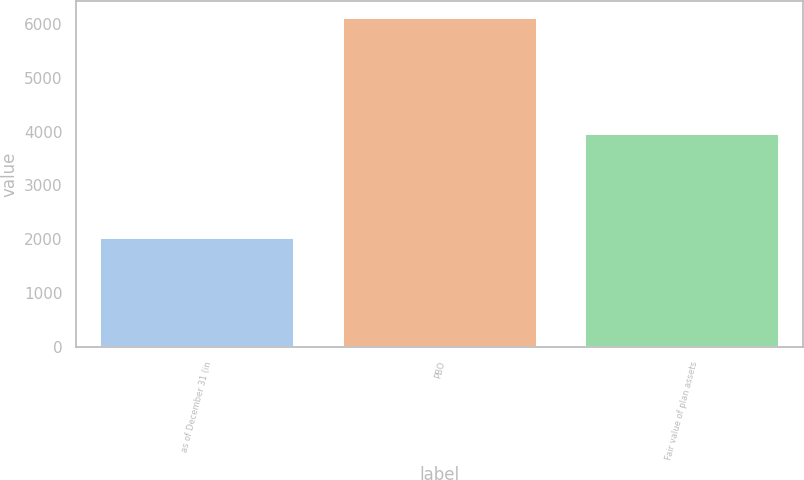Convert chart. <chart><loc_0><loc_0><loc_500><loc_500><bar_chart><fcel>as of December 31 (in<fcel>PBO<fcel>Fair value of plan assets<nl><fcel>2014<fcel>6117<fcel>3954<nl></chart> 